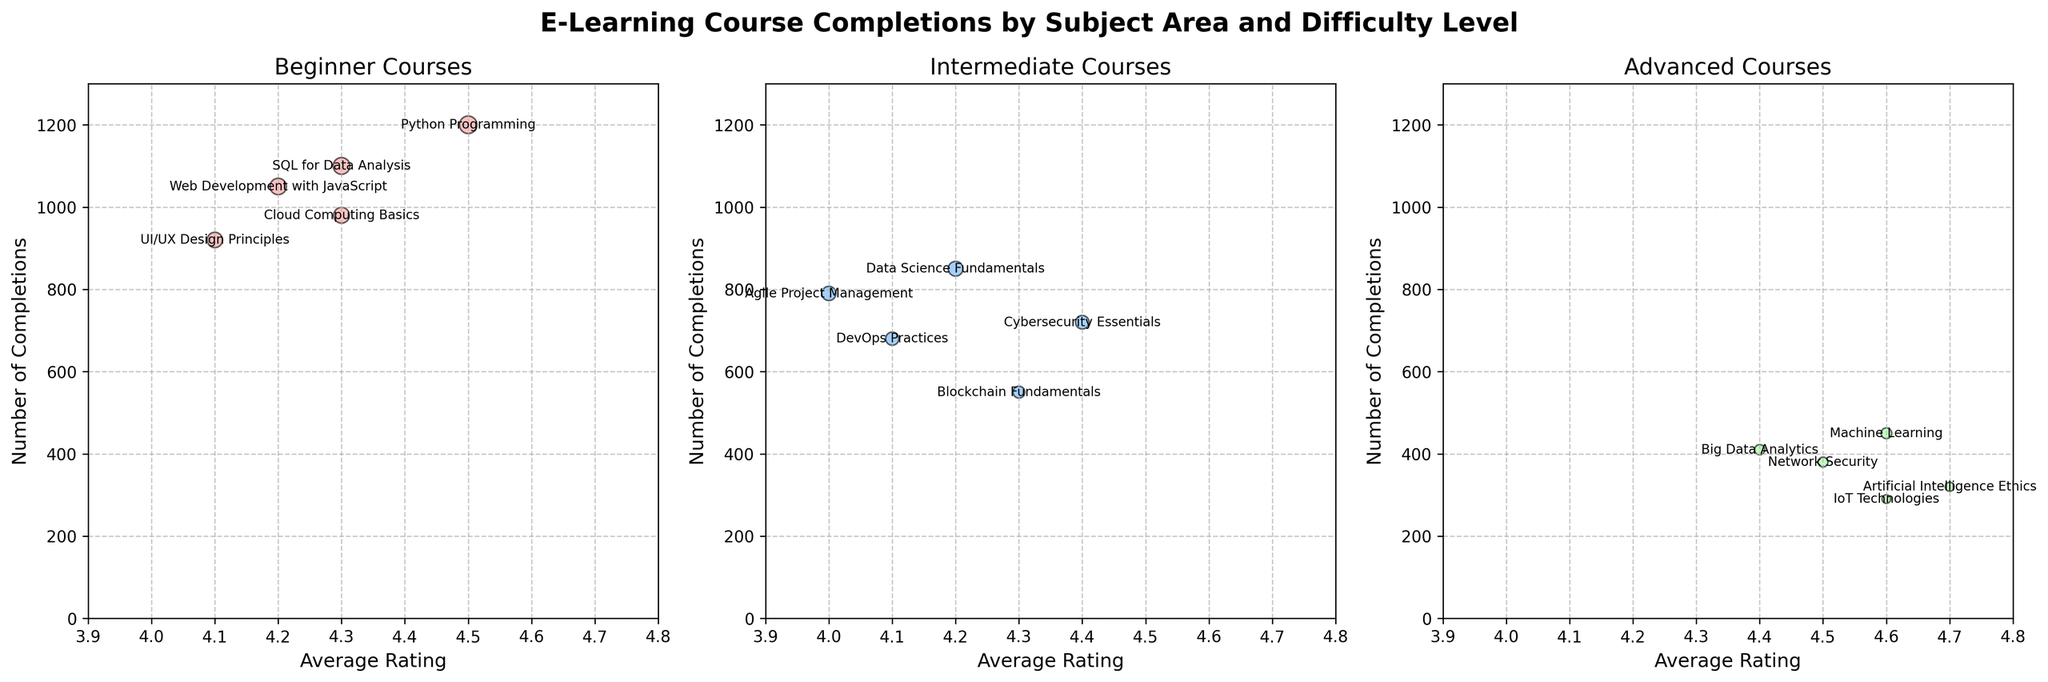Which difficulty level has the highest number of course completions overall? By examining the individual y-values (Number of Completions) in each plot, the 'Beginner' level courses have the highest values, with Python Programming reaching 1200 completions, followed by SQL for Data Analysis with 1100 completions.
Answer: Beginner What is the title of the figure? The title is clearly shown at the top and reads 'E-Learning Course Completions by Subject Area and Difficulty Level'.
Answer: E-Learning Course Completions by Subject Area and Difficulty Level Which course at the Advanced level has the highest average rating? In the plot for Advanced courses, the bubble with the highest x-value (Average Rating) is for Artificial Intelligence Ethics with a rating of 4.7.
Answer: Artificial Intelligence Ethics How many courses are represented in the Intermediate plot? By counting the individual bubbles (data points) in the Intermediate plot, there are 5 courses represented.
Answer: 5 Is the number of completions for 'Machine Learning' greater than that for 'Big Data Analytics'? By comparing their y-values (Number of Completions) in the Advanced plot, Machine Learning has 450 completions, which is greater than Big Data Analytics' 410 completions.
Answer: Yes Which Intermediate course has the lowest number of completions? In the Intermediate plot, the bubble with the lowest y-value (Number of Completions) represents Blockchain Fundamentals with 550 completions.
Answer: Blockchain Fundamentals What is the average rating of 'Python Programming' and how does it compare to 'Web Development with JavaScript'? From the Beginner plot, 'Python Programming' has an average rating of 4.5, whereas 'Web Development with JavaScript' has a rating of 4.2. Thus, Python Programming has a higher average rating.
Answer: 4.5; Higher Arrange the Beginner courses in decreasing order of completions. By comparing the y-values (Number of Completions) in the Beginner plot, the descending order is: Python Programming (1200), SQL for Data Analysis (1100), Web Development with JavaScript (1050), Cloud Computing Basics (980), and UI/UX Design Principles (920).
Answer: Python Programming, SQL for Data Analysis, Web Development with JavaScript, Cloud Computing Basics, UI/UX Design Principles What is the general relationship between the average rating and the number of completions for the Beginner courses? On the Beginner plot, bubbles tend to be positioned at higher completions and fairly high average ratings. This suggests a favorable trend where courses with higher completions also have higher average ratings.
Answer: Positive trend Which Advanced course has the lowest number of completions? In the Advanced plot, the bubble with the lowest y-value (Number of Completions) is for IoT Technologies with 290 completions.
Answer: IoT Technologies 